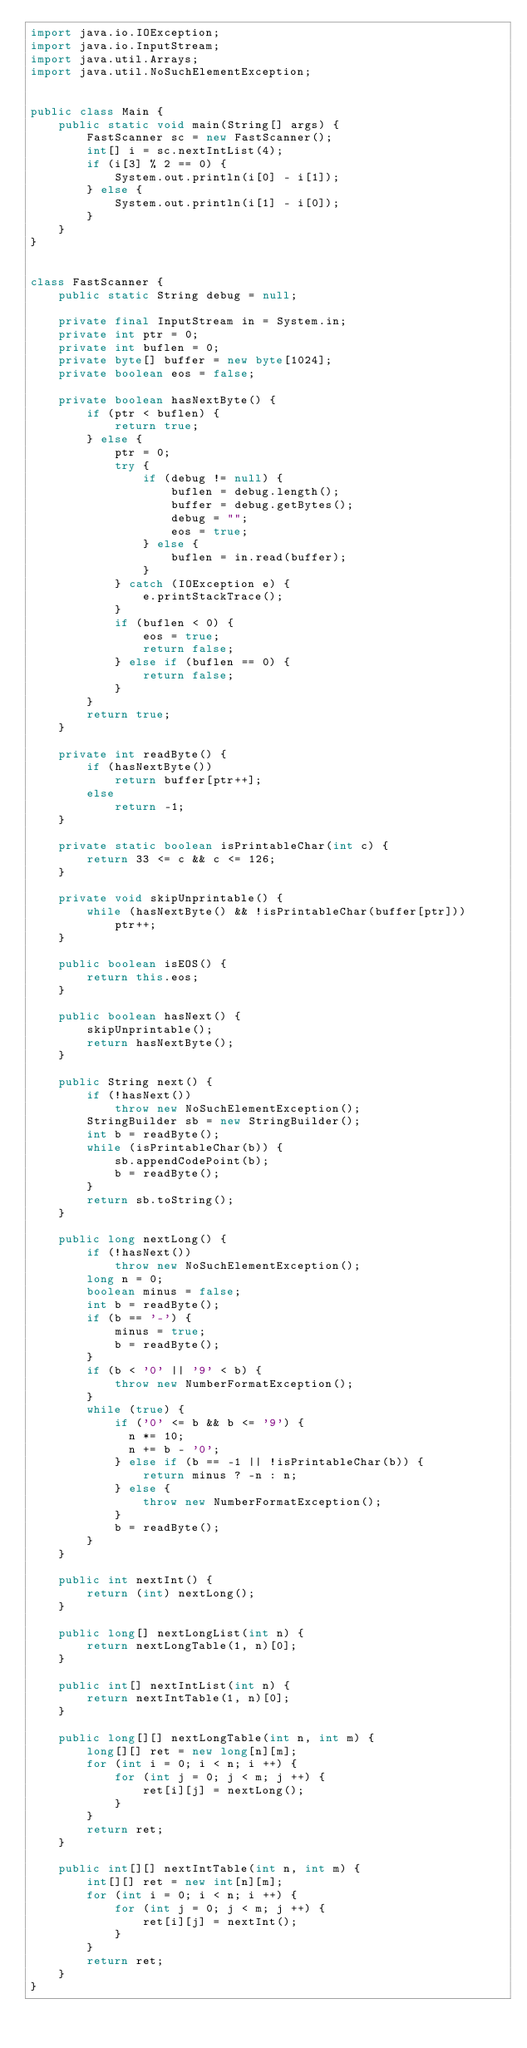Convert code to text. <code><loc_0><loc_0><loc_500><loc_500><_Java_>import java.io.IOException;
import java.io.InputStream;
import java.util.Arrays;
import java.util.NoSuchElementException;


public class Main {
    public static void main(String[] args) {
        FastScanner sc = new FastScanner();
        int[] i = sc.nextIntList(4);
        if (i[3] % 2 == 0) {
            System.out.println(i[0] - i[1]);
        } else {
            System.out.println(i[1] - i[0]);
        }
    }
}


class FastScanner {
    public static String debug = null;

    private final InputStream in = System.in;
    private int ptr = 0;
    private int buflen = 0;
    private byte[] buffer = new byte[1024];
    private boolean eos = false;

    private boolean hasNextByte() {
        if (ptr < buflen) {
            return true;
        } else {
            ptr = 0;
            try {
                if (debug != null) {
                    buflen = debug.length();
                    buffer = debug.getBytes();
                    debug = "";
                    eos = true;
                } else {
                    buflen = in.read(buffer);
                }
            } catch (IOException e) {
                e.printStackTrace();
            }
            if (buflen < 0) {
                eos = true;
                return false;
            } else if (buflen == 0) {
                return false;
            }
        }
        return true;
    }

    private int readByte() {
        if (hasNextByte())
            return buffer[ptr++];
        else
            return -1;
    }

    private static boolean isPrintableChar(int c) {
        return 33 <= c && c <= 126;
    }

    private void skipUnprintable() {
        while (hasNextByte() && !isPrintableChar(buffer[ptr]))
            ptr++;
    }

    public boolean isEOS() {
        return this.eos;
    }

    public boolean hasNext() {
        skipUnprintable();
        return hasNextByte();
    }

    public String next() {
        if (!hasNext())
            throw new NoSuchElementException();
        StringBuilder sb = new StringBuilder();
        int b = readByte();
        while (isPrintableChar(b)) {
            sb.appendCodePoint(b);
            b = readByte();
        }
        return sb.toString();
    }

    public long nextLong() {
        if (!hasNext())
            throw new NoSuchElementException();
        long n = 0;
        boolean minus = false;
        int b = readByte();
        if (b == '-') {
            minus = true;
            b = readByte();
        }
        if (b < '0' || '9' < b) {
            throw new NumberFormatException();
        }
        while (true) {
            if ('0' <= b && b <= '9') {
              n *= 10;
              n += b - '0';
            } else if (b == -1 || !isPrintableChar(b)) {
                return minus ? -n : n;
            } else {
                throw new NumberFormatException();
            }
            b = readByte();
        }
    }

    public int nextInt() {
        return (int) nextLong();
    }

    public long[] nextLongList(int n) {
        return nextLongTable(1, n)[0];
    }

    public int[] nextIntList(int n) {
        return nextIntTable(1, n)[0];
    }

    public long[][] nextLongTable(int n, int m) {
        long[][] ret = new long[n][m];
        for (int i = 0; i < n; i ++) {
            for (int j = 0; j < m; j ++) {
                ret[i][j] = nextLong();
            }
        }
        return ret;
    }

    public int[][] nextIntTable(int n, int m) {
        int[][] ret = new int[n][m];
        for (int i = 0; i < n; i ++) {
            for (int j = 0; j < m; j ++) {
                ret[i][j] = nextInt();
            }
        }
        return ret;
    }
}
</code> 